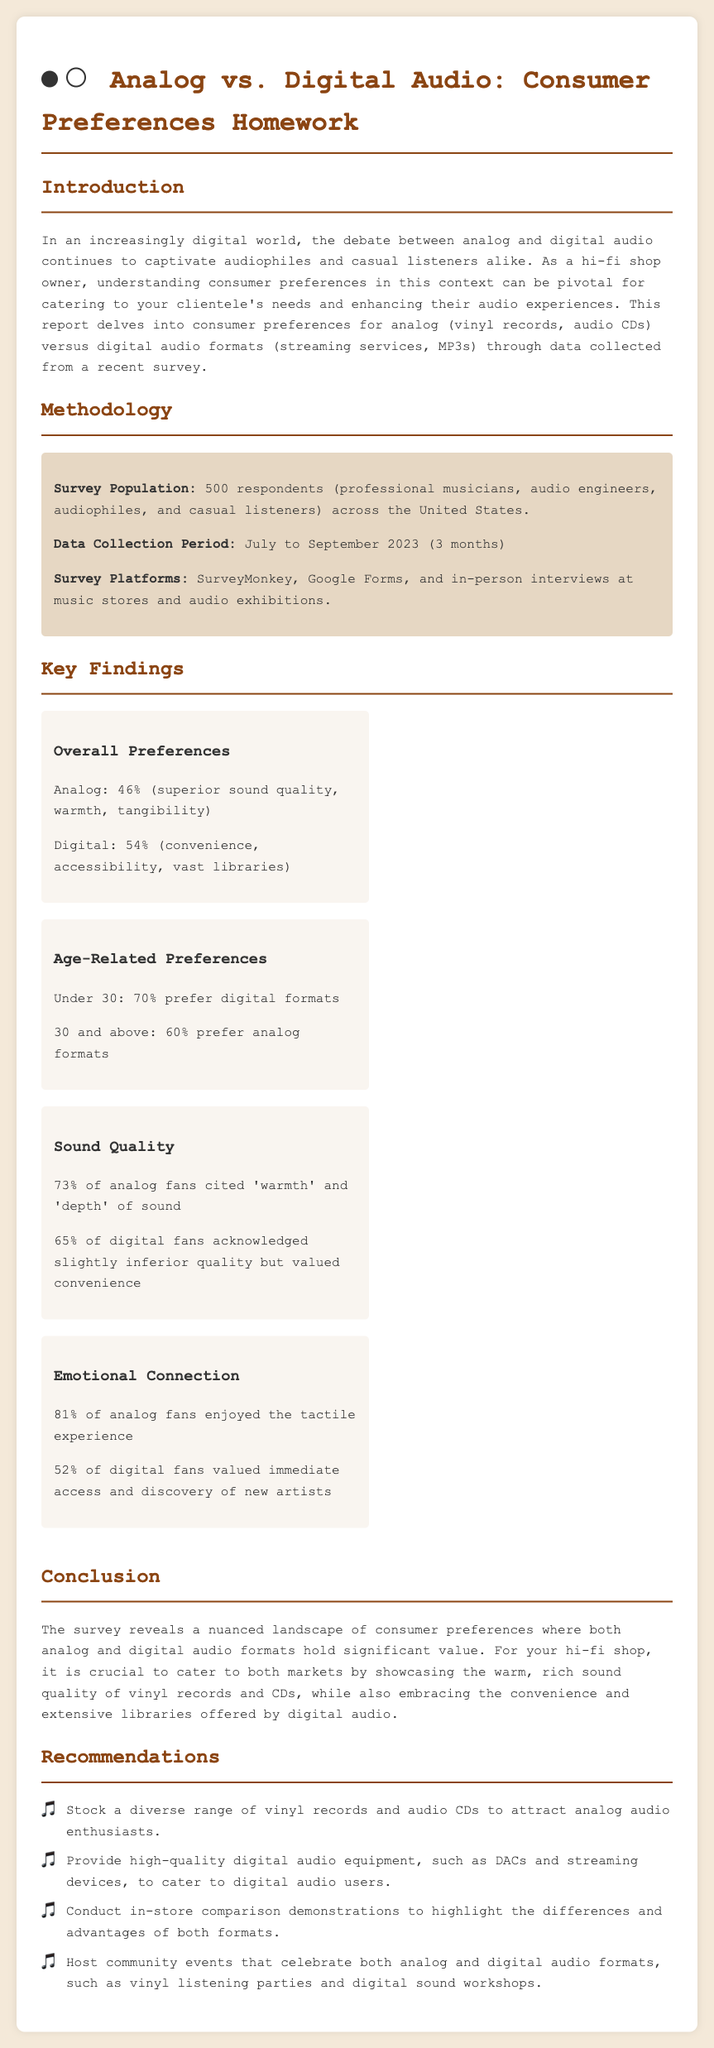What was the survey population size? The survey included 500 respondents.
Answer: 500 respondents What percentage of analog fans cited 'warmth' and 'depth' of sound? 73% of analog fans mentioned these qualities in the survey.
Answer: 73% What was the data collection period for the survey? The survey was conducted from July to September 2023.
Answer: July to September 2023 What do 70% of respondents under 30 prefer? The data shows that 70% of that age group prefers digital formats.
Answer: Digital formats What event type is recommended for engaging with the community? The document suggests hosting vinyl listening parties.
Answer: Vinyl listening parties Which audio format did 54% of respondents prefer overall? The survey indicated that the majority, 54%, preferred digital audio.
Answer: Digital What percentage of digital fans valued convenience? The document states that 65% of digital fans acknowledged this attribute.
Answer: 65% What type of audio equipment should the shop provide according to recommendations? The report recommends providing high-quality digital audio equipment.
Answer: Digital audio equipment 